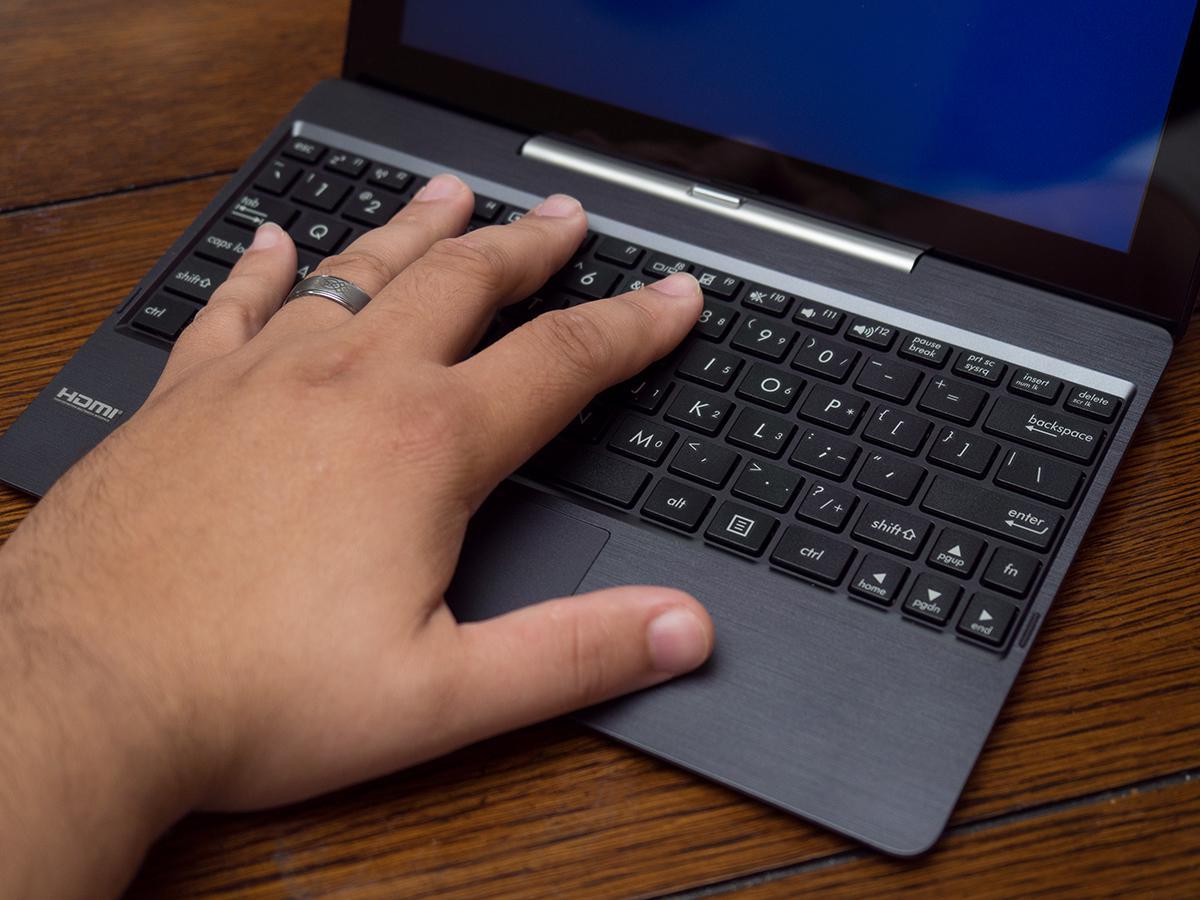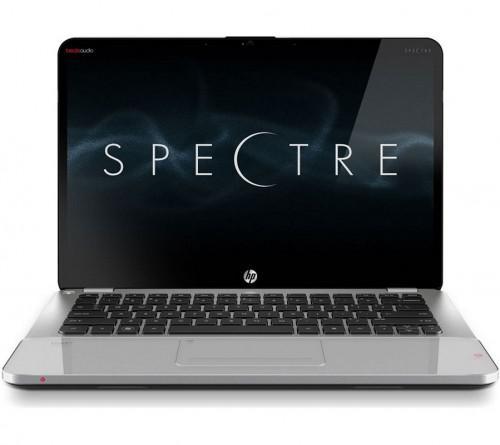The first image is the image on the left, the second image is the image on the right. Analyze the images presented: Is the assertion "Exactly two open laptops can be seen on the image on the right." valid? Answer yes or no. No. The first image is the image on the left, the second image is the image on the right. Evaluate the accuracy of this statement regarding the images: "One image shows side by side open laptops, and the other shows a small laptop resting on top of a bigger one.". Is it true? Answer yes or no. No. 